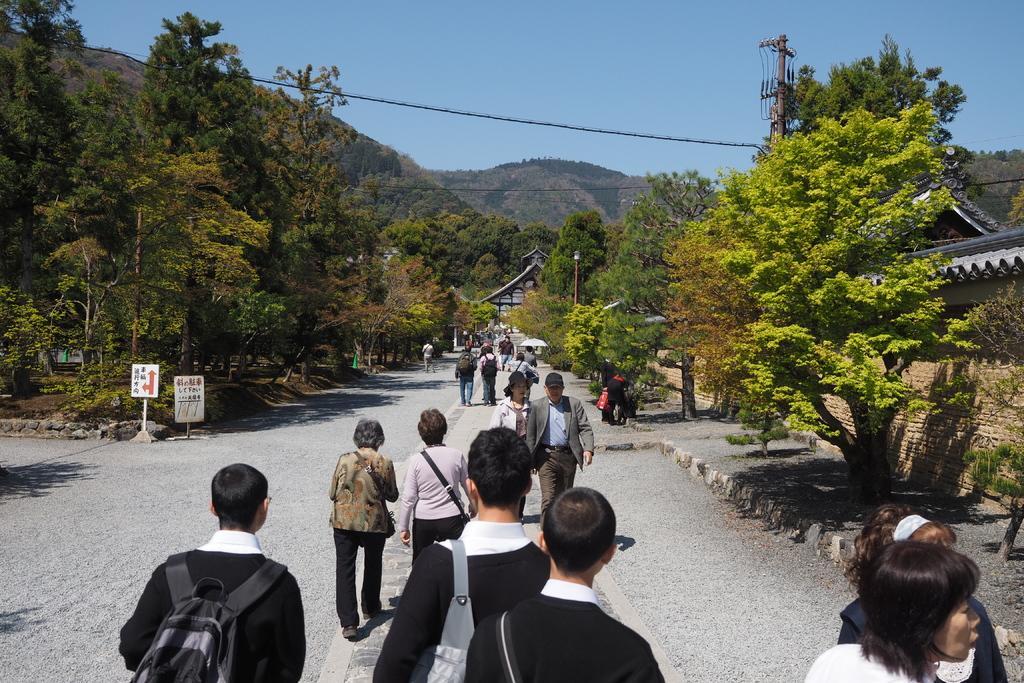Can you describe this image briefly? In the image there are many people walking on the road with bags and there are trees on either side of it, in the background there are hills covered with trees and above its sky. 